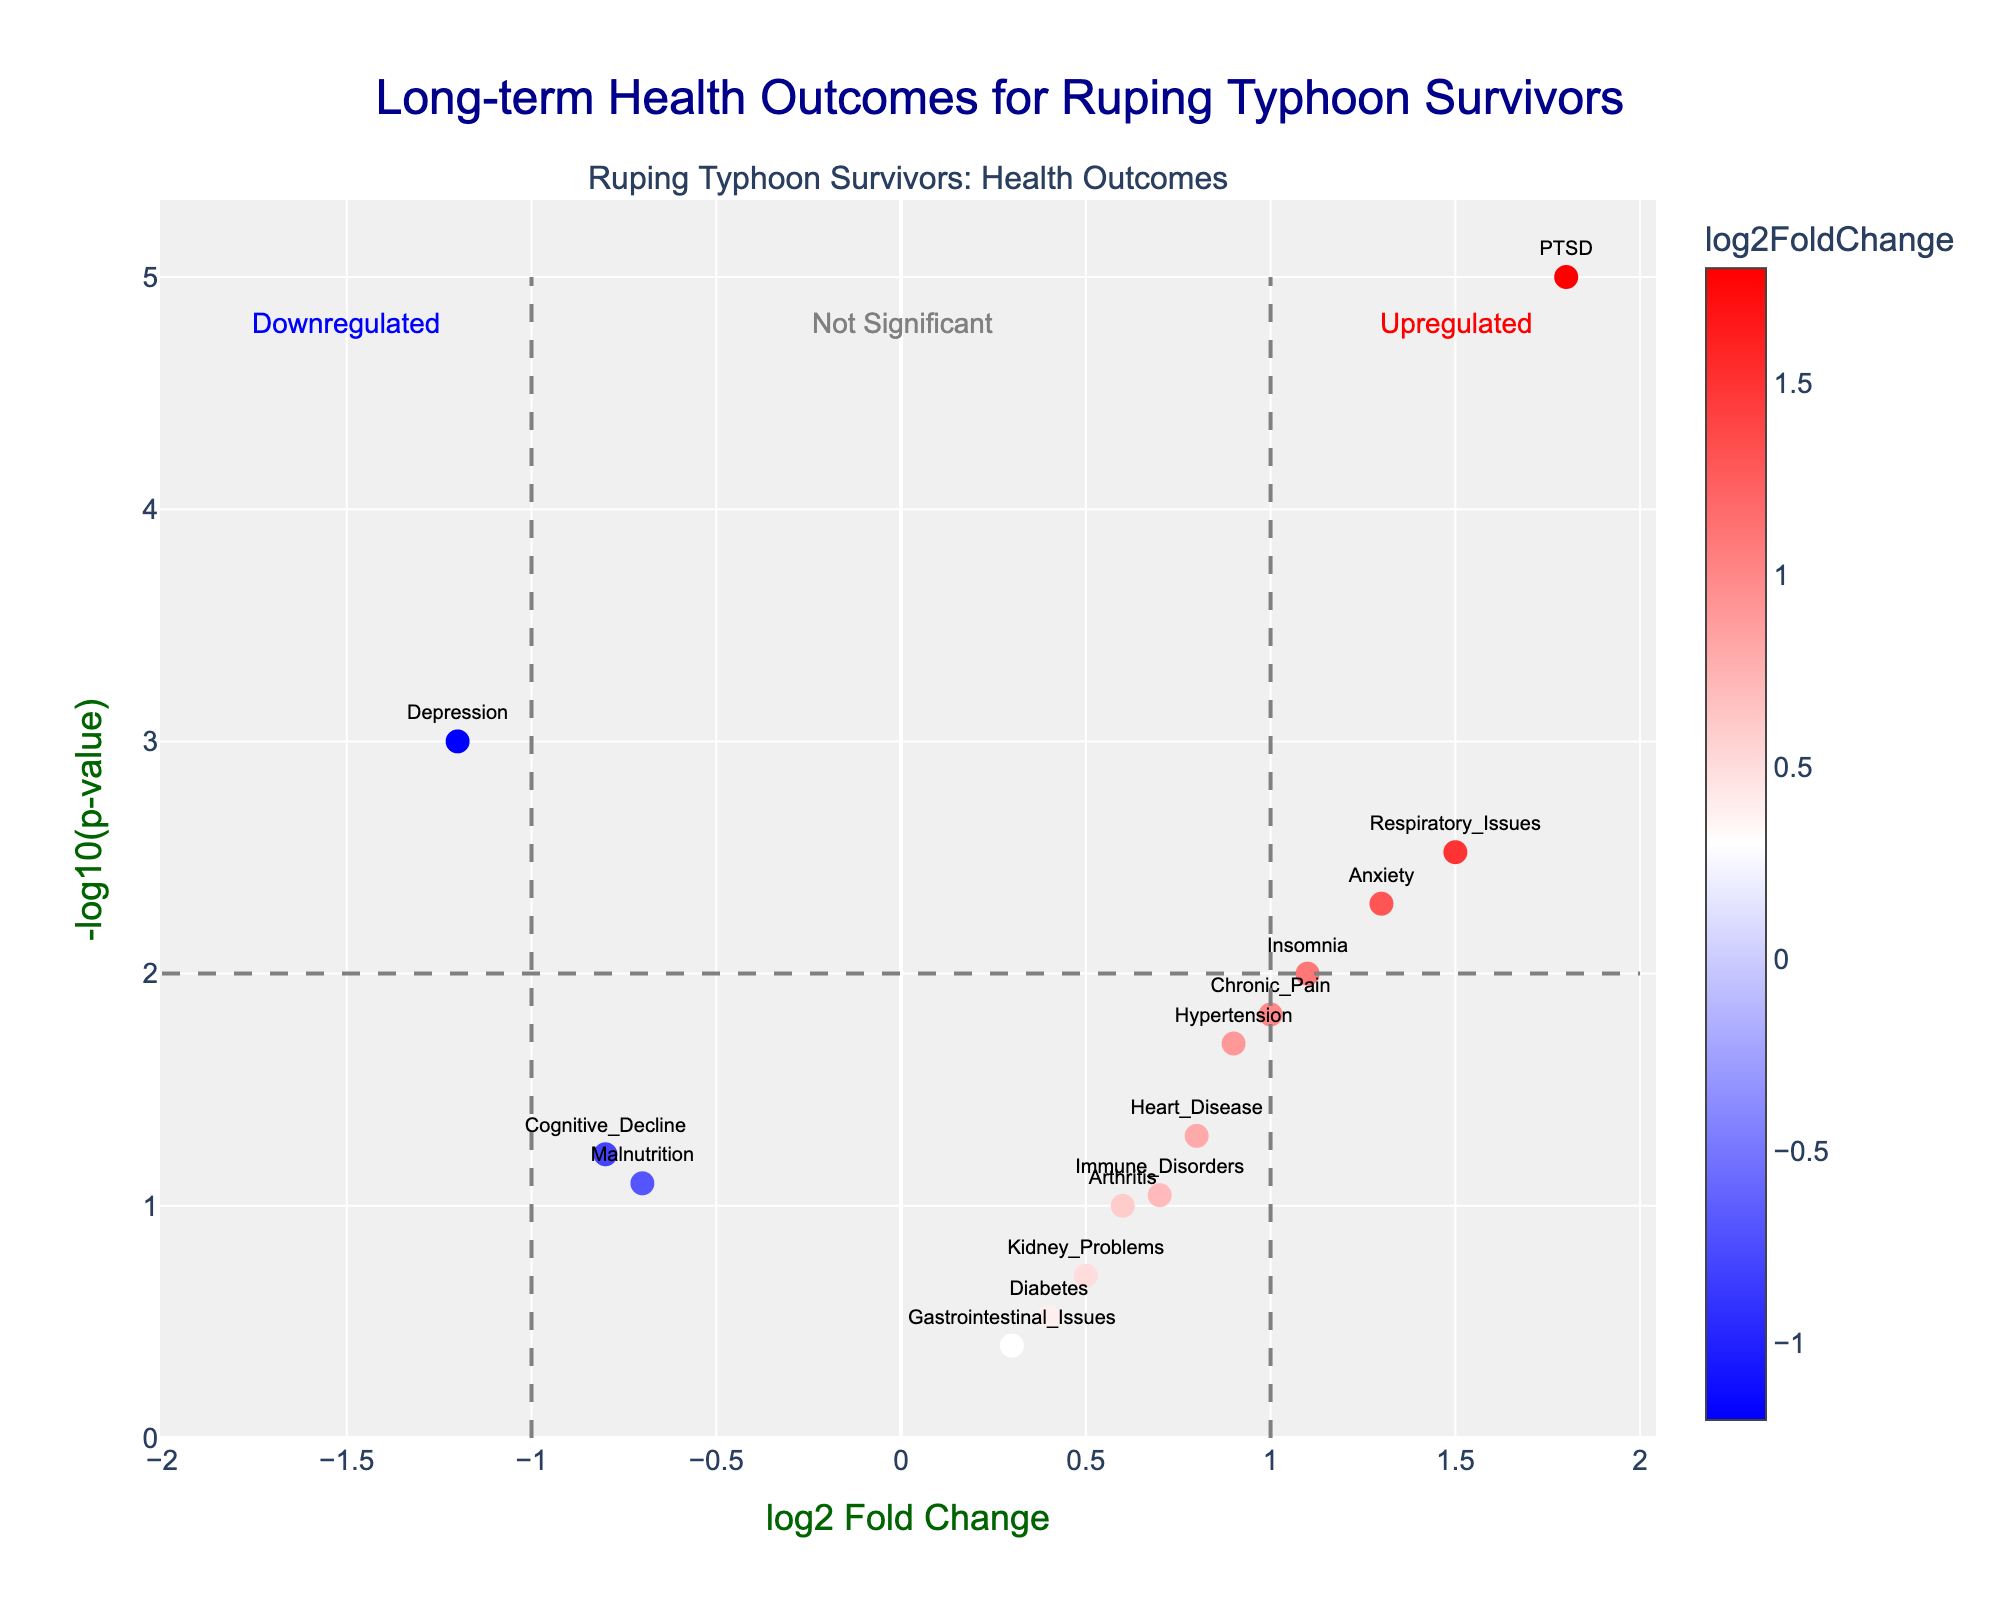What is the title of the plot? The title is displayed at the top center of the plot, describing its main subject.
Answer: Long-term Health Outcomes for Ruping Typhoon Survivors How many data points are labeled as either "Upregulated" or "Downregulated"? Identify labels within the gray dashed lines, representing "Upregulated" to the right and "Downregulated" to the left. Count the distinct points in these regions.
Answer: 9 Which condition has the highest -log10(p-value)? Look for the data point with the maximum y-value (-log10(p-value)) in the plot. It corresponds to the condition with the smallest p-value.
Answer: PTSD Which condition has the lowest log2FoldChange? Identify the data point with the minimum x-value (log2FoldChange) in the plot.
Answer: Depression Are there any conditions with a log2FoldChange close to 0 but a significant p-value? Examine points near the vertical axis (log2FoldChange ≈ 0) and check if their y-values (-log10(p-value)) are high, indicating significance.
Answer: No Of the conditions that are "Upregulated," which has the smallest log2FoldChange? Among points in the "Upregulated" region (right side of x-axis), find the one with the lowest x-value.
Answer: Hypertension Compare the -log10(p-value) of "Anxiety" with "Hypertension." Which is higher? Check the y-values of Anxiety and Hypertension to determine which one is greater.
Answer: Anxiety Are there any points that fall below the threshold lines but are still labeled as significant based on their p-value? Review points outside the labeled "Upregulated" and "Downregulated" regions but with high y-values indicating significance.
Answer: No How many conditions have a log2FoldChange > 1? Count all data points with x-values (log2FoldChange) greater than 1.
Answer: 4 Which has a higher -log10(p-value), "Insomnia" or "Respiratory_Issues"? Compare the y-values (-log10(p-value)) of Insomnia and Respiratory Issues to determine which is higher.
Answer: Respiratory Issues 